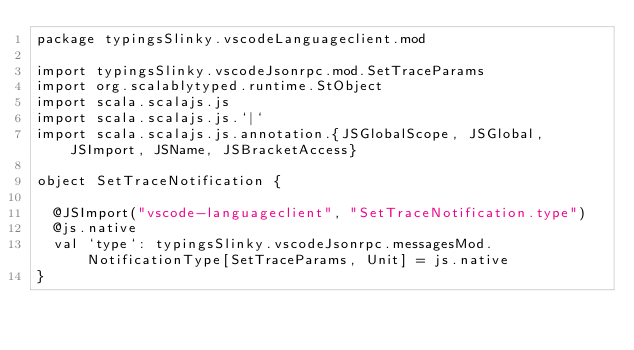Convert code to text. <code><loc_0><loc_0><loc_500><loc_500><_Scala_>package typingsSlinky.vscodeLanguageclient.mod

import typingsSlinky.vscodeJsonrpc.mod.SetTraceParams
import org.scalablytyped.runtime.StObject
import scala.scalajs.js
import scala.scalajs.js.`|`
import scala.scalajs.js.annotation.{JSGlobalScope, JSGlobal, JSImport, JSName, JSBracketAccess}

object SetTraceNotification {
  
  @JSImport("vscode-languageclient", "SetTraceNotification.type")
  @js.native
  val `type`: typingsSlinky.vscodeJsonrpc.messagesMod.NotificationType[SetTraceParams, Unit] = js.native
}
</code> 